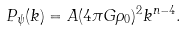<formula> <loc_0><loc_0><loc_500><loc_500>P _ { \psi } ( k ) = A ( 4 \pi G \rho _ { 0 } ) ^ { 2 } k ^ { n - 4 } .</formula> 